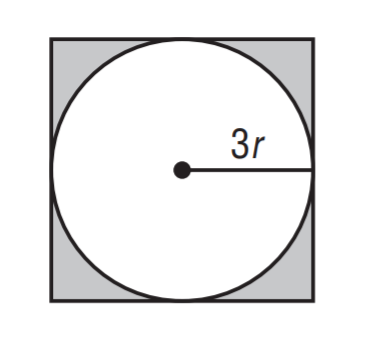Answer the mathemtical geometry problem and directly provide the correct option letter.
Question: Find the ratio of the area of the circle to the area of the square.
Choices: A: \frac { \pi } { 4 } B: \frac { \pi } { 2 } C: \frac { 3 \pi } { 4 } D: \pi A 